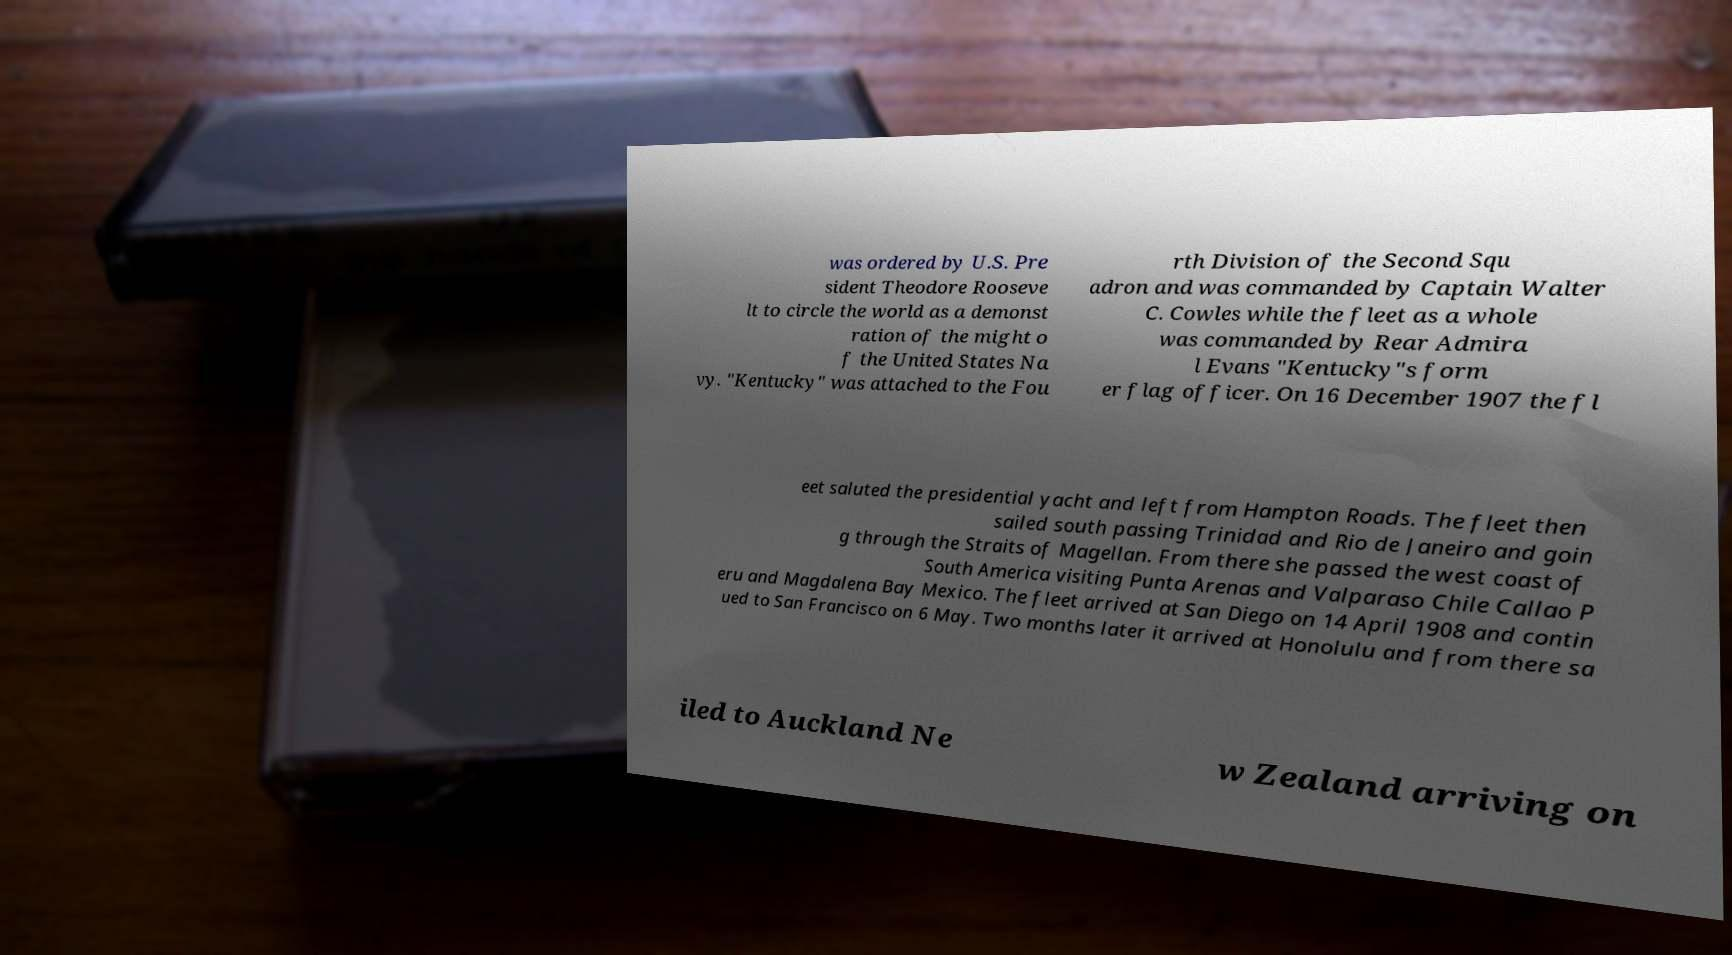For documentation purposes, I need the text within this image transcribed. Could you provide that? was ordered by U.S. Pre sident Theodore Rooseve lt to circle the world as a demonst ration of the might o f the United States Na vy. "Kentucky" was attached to the Fou rth Division of the Second Squ adron and was commanded by Captain Walter C. Cowles while the fleet as a whole was commanded by Rear Admira l Evans "Kentucky"s form er flag officer. On 16 December 1907 the fl eet saluted the presidential yacht and left from Hampton Roads. The fleet then sailed south passing Trinidad and Rio de Janeiro and goin g through the Straits of Magellan. From there she passed the west coast of South America visiting Punta Arenas and Valparaso Chile Callao P eru and Magdalena Bay Mexico. The fleet arrived at San Diego on 14 April 1908 and contin ued to San Francisco on 6 May. Two months later it arrived at Honolulu and from there sa iled to Auckland Ne w Zealand arriving on 